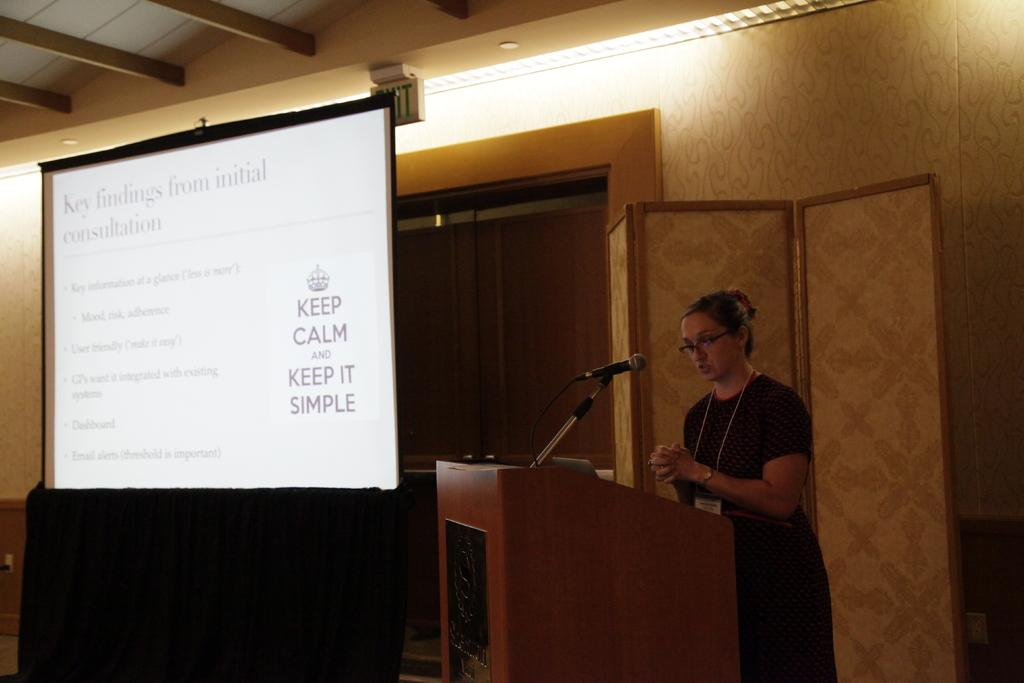Who is the main subject in the image? There is a woman in the image. What is the woman wearing? The woman is wearing a black dress. Where is the woman standing in the image? The woman is standing in front of a dias. What is the woman doing in the image? The woman is talking on a mic. What is present on the wall beside the woman? There is a screen on the wall beside the woman. What can be seen on the ceiling in the image? There are lights on the ceiling. What type of drug is the woman holding in the image? There is no drug present in the image; the woman is holding a mic. What shape is the suit the woman is wearing in the image? The woman is not wearing a suit in the image; she is wearing a black dress. 